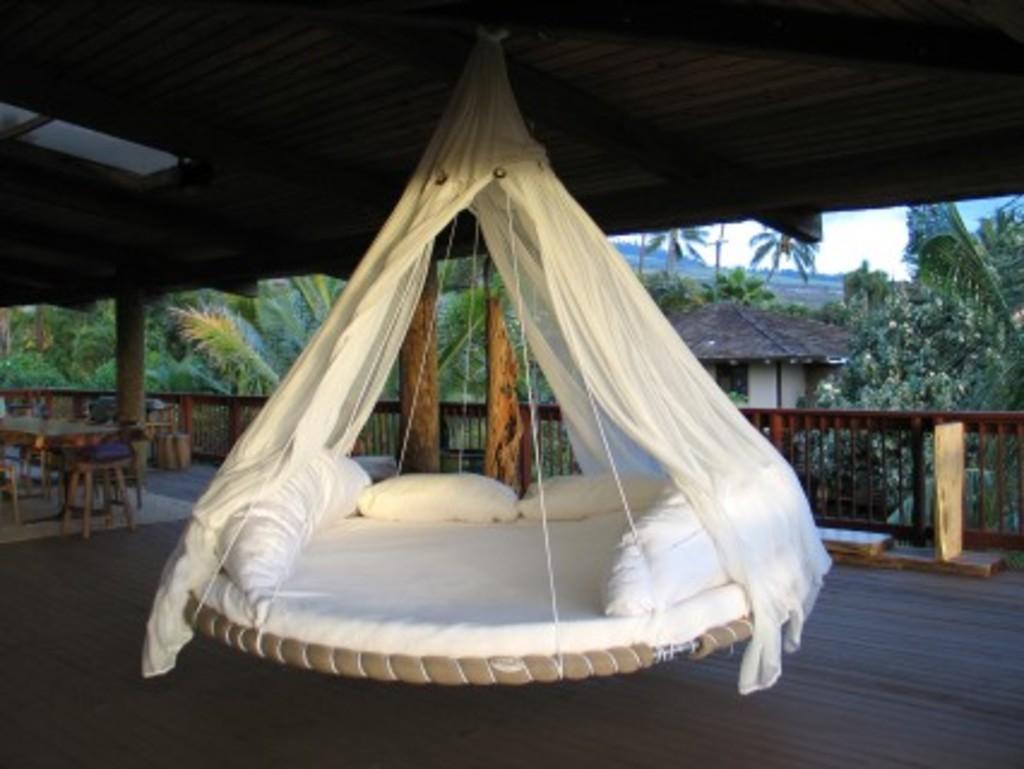Could you give a brief overview of what you see in this image? At the center of the image there is a round bed hanging to the ceiling, on the left side of the image there is a table and stools and there is a railing. In the background there is a house, trees and a sky. 